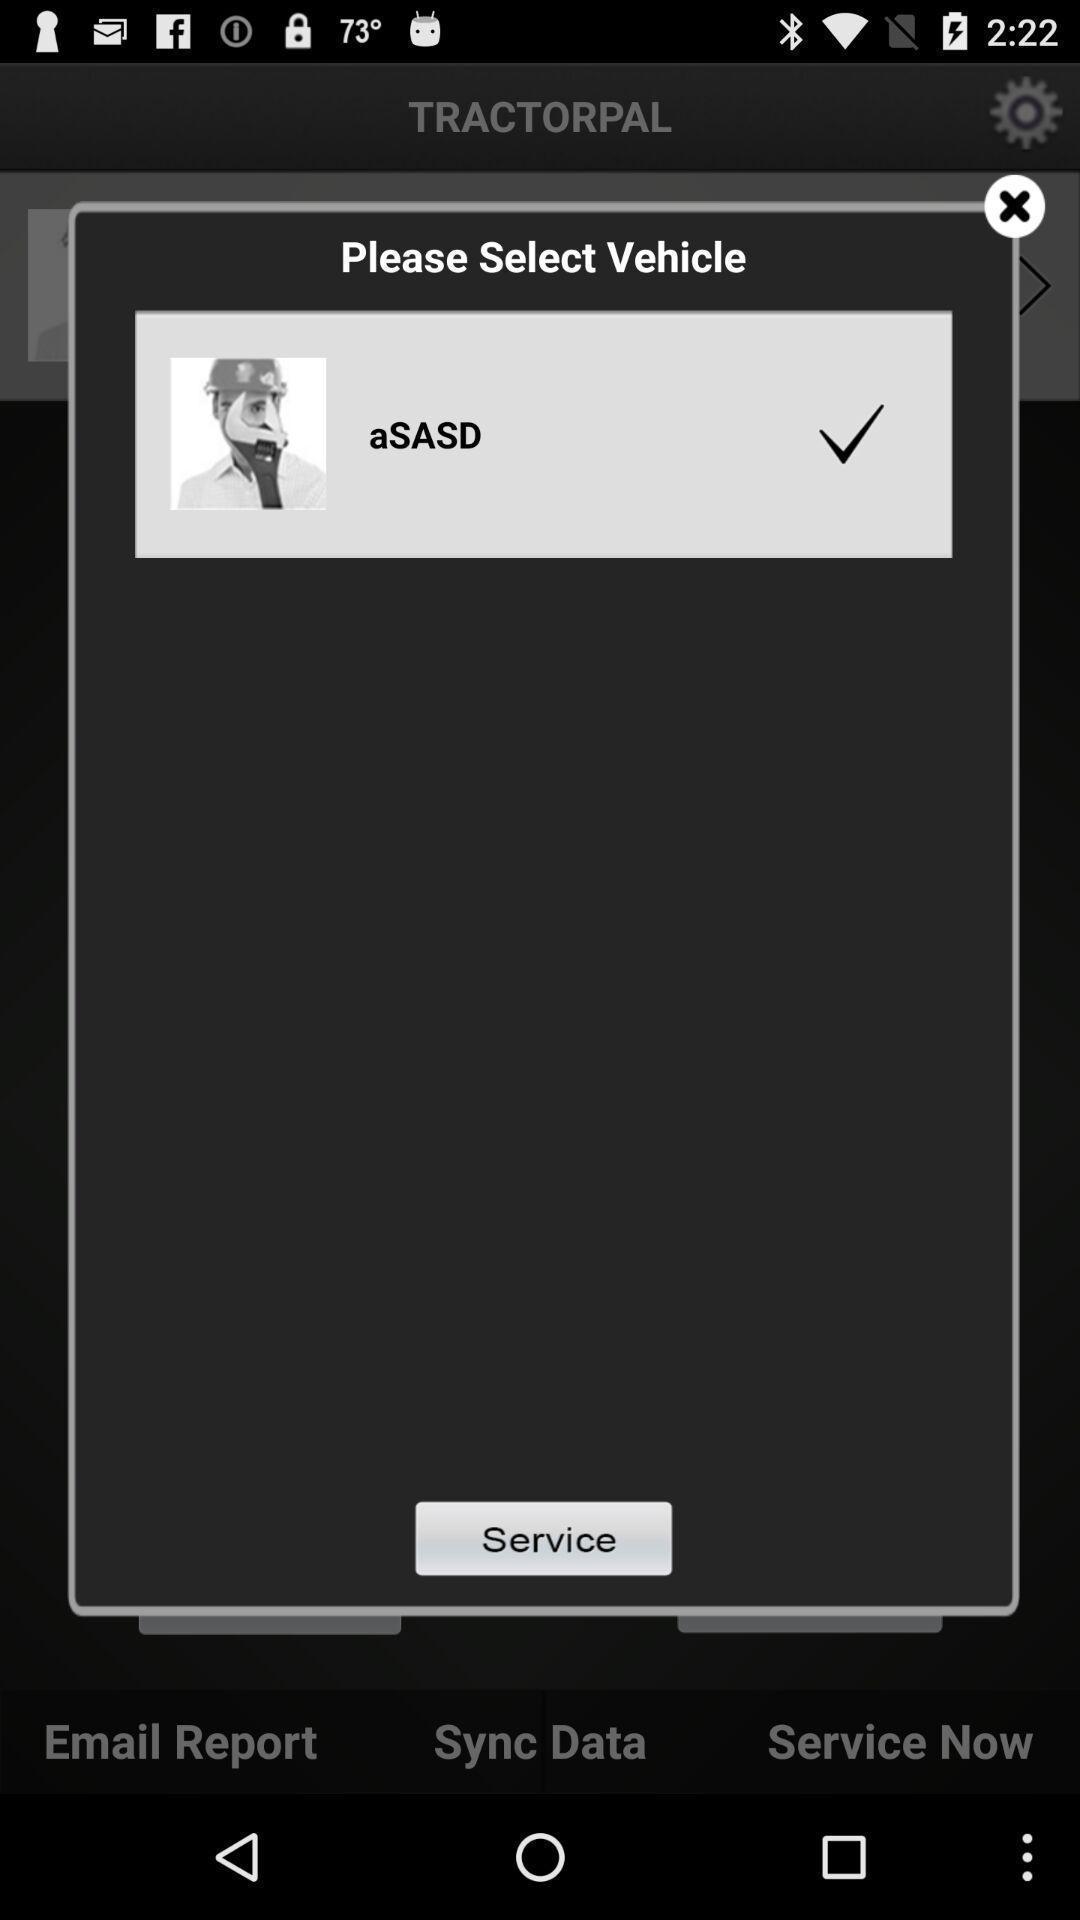Give me a narrative description of this picture. Popup showing about service available. 